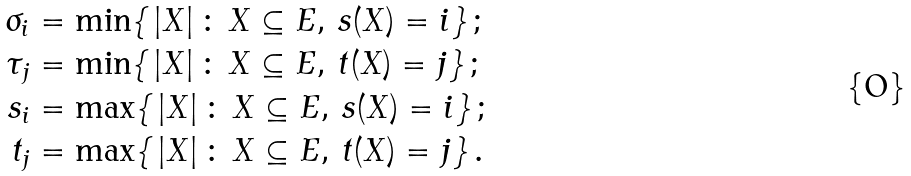<formula> <loc_0><loc_0><loc_500><loc_500>\sigma _ { i } & = \min \{ \, | X | \, \colon \, X \subseteq E , \, s ( X ) = i \} \, ; \\ \tau _ { j } & = \min \{ \, | X | \, \colon \, X \subseteq E , \, t ( X ) = j \} \, ; \\ s _ { i } & = \max \{ \, | X | \, \colon \, X \subseteq E , \, s ( X ) = i \} \, ; \\ t _ { j } & = \max \{ \, | X | \, \colon \, X \subseteq E , \, t ( X ) = j \} \, .</formula> 